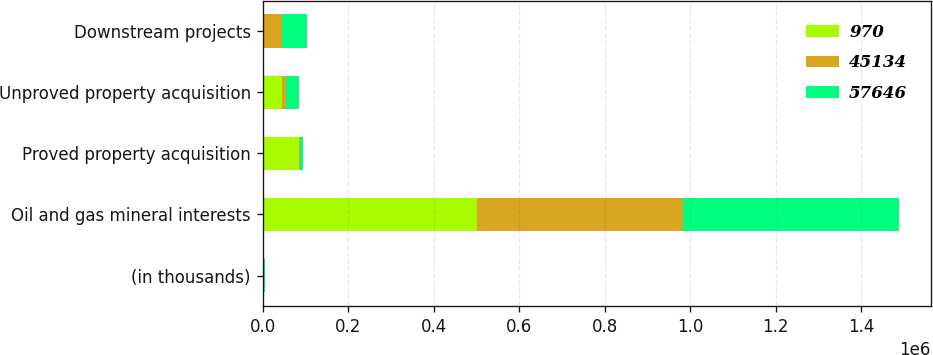Convert chart. <chart><loc_0><loc_0><loc_500><loc_500><stacked_bar_chart><ecel><fcel>(in thousands)<fcel>Oil and gas mineral interests<fcel>Proved property acquisition<fcel>Unproved property acquisition<fcel>Downstream projects<nl><fcel>970<fcel>2004<fcel>501119<fcel>85785<fcel>44681<fcel>970<nl><fcel>45134<fcel>2003<fcel>481236<fcel>1294<fcel>10234<fcel>45134<nl><fcel>57646<fcel>2002<fcel>505464<fcel>7988<fcel>30515<fcel>57646<nl></chart> 